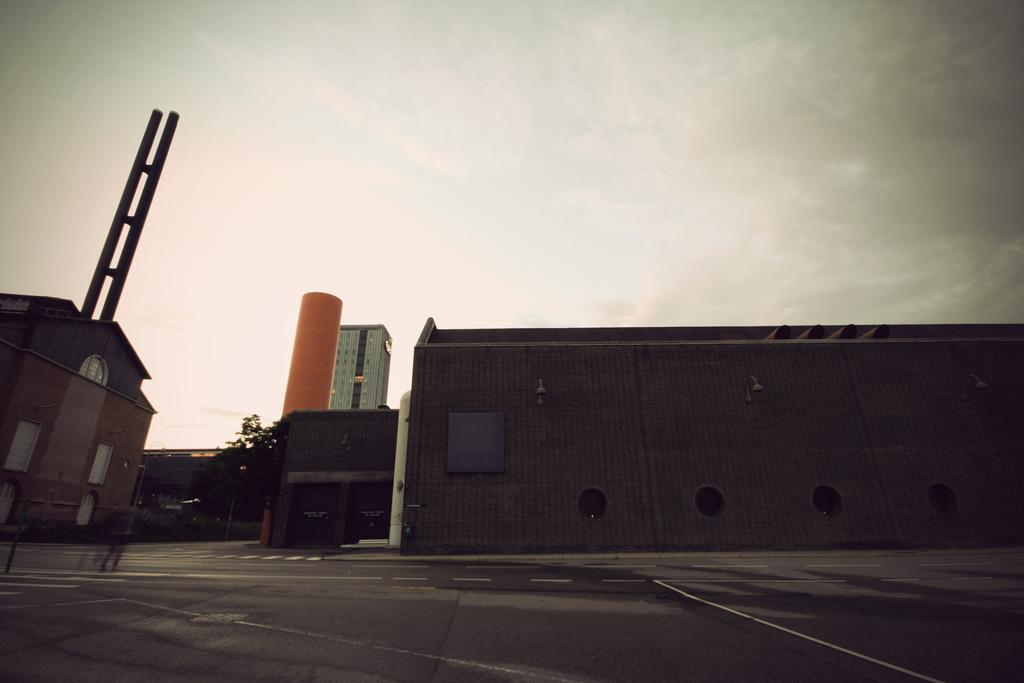What type of structures can be seen in the image? There are buildings in the image. Where is the tree located in the image? The tree is on the left side of the image. What is visible at the top of the image? The sky is visible at the top of the image. What type of flesh can be seen hanging from the buildings in the image? There is no flesh present in the image; it features buildings, a tree, and the sky. 